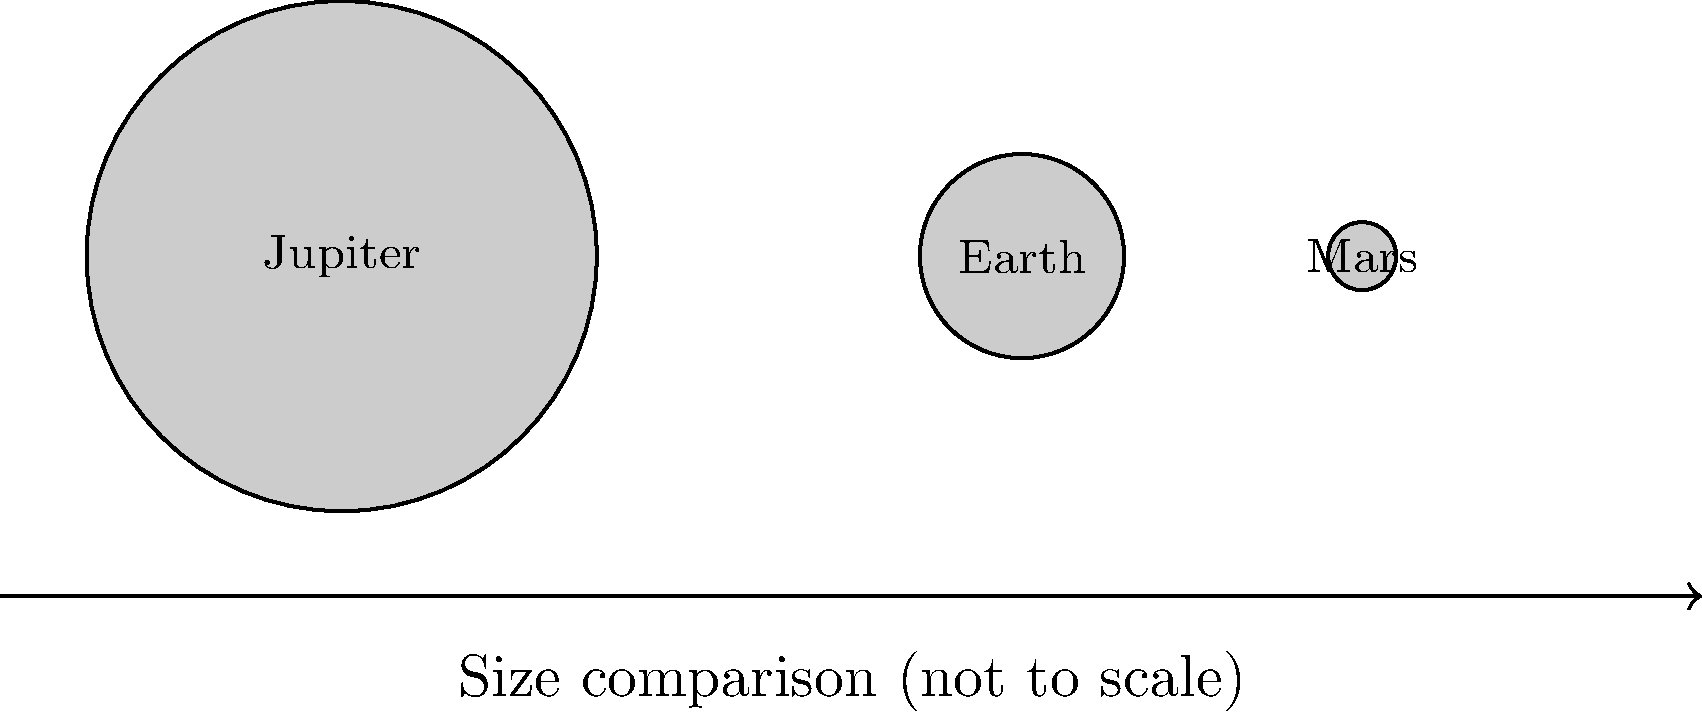As a pharmacist concerned with drug safety, precision in measurements is crucial. Similarly, in astronomy, accurate size comparisons are essential. Based on the diagram, which shows a simplified representation of Jupiter, Earth, and Mars (not to scale), approximately how many Earths could fit inside Jupiter by volume? To determine how many Earths could fit inside Jupiter by volume, we need to follow these steps:

1. Observe the relative sizes in the diagram:
   Jupiter's radius ≈ 2.5 times Earth's radius

2. Recall the formula for the volume of a sphere:
   $V = \frac{4}{3}\pi r^3$

3. Set up the ratio of Jupiter's volume to Earth's volume:
   $\frac{V_J}{V_E} = \frac{\frac{4}{3}\pi r_J^3}{\frac{4}{3}\pi r_E^3} = (\frac{r_J}{r_E})^3$

4. Substitute the relative radii:
   $(\frac{r_J}{r_E})^3 = (2.5)^3 = 15.625$

5. Round to the nearest whole number:
   ≈ 1,300 Earths

This calculation shows that approximately 1,300 Earths could fit inside Jupiter by volume. This large difference emphasizes the importance of precise measurements and scale in both astronomy and pharmacy, where small variations can have significant impacts.
Answer: Approximately 1,300 Earths 